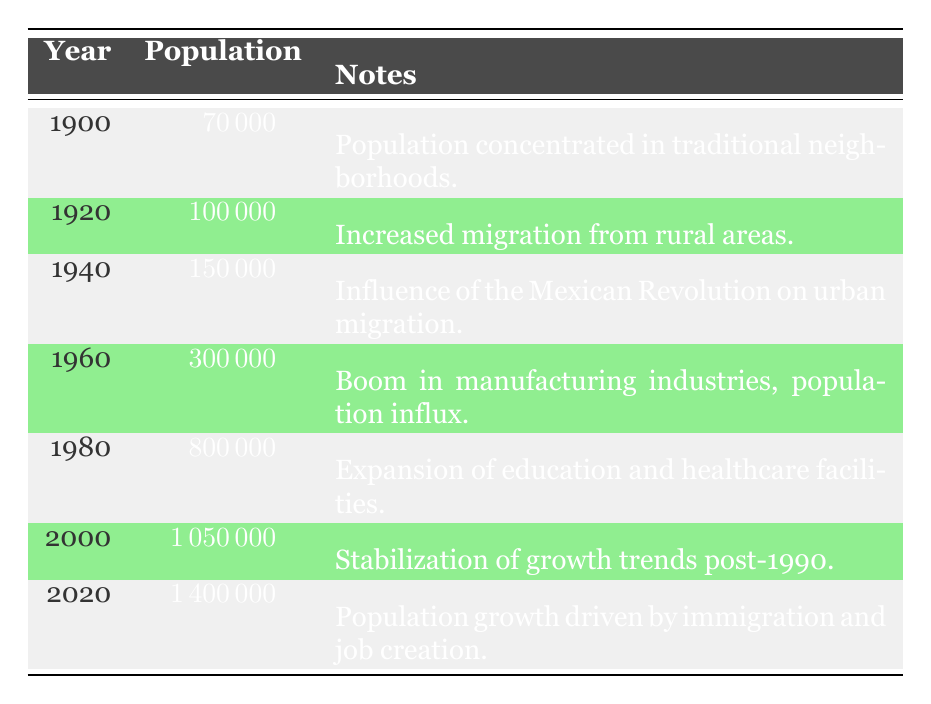What was the population of Monterrey in 1900? The table indicates that the population in 1900 was 70,000.
Answer: 70,000 What year saw a population of 1,000,000? According to the table, the population reached 1,000,000 in 1990.
Answer: 1990 Which year had the highest population growth compared to the previous decade? The decade with the most significant increase occurred from 1970 to 1980, where the population grew from 600,000 to 800,000, an increase of 200,000.
Answer: 1970 to 1980 Was the population of Monterrey less than 1,000,000 in 1990? No, the table shows that the population was indeed 1,000,000 in 1990, meaning it was not less.
Answer: No What was the population difference between 1940 and 1920? The populations were 150,000 in 1940 and 100,000 in 1920, so the difference is 150,000 - 100,000 = 50,000.
Answer: 50,000 In which years did the population double compared to the previous recorded population? The population doubled between 1940 (150,000) and 1950 (200,000), and again between 1960 (300,000) and 1970 (600,000).
Answer: 1940 to 1950 and 1960 to 1970 What was the population of Monterrey in 2020 compared to 1900? The population in 2020 was 1,400,000, which shows a significant increase compared to 70,000 in 1900. Specifically, the difference is 1,400,000 - 70,000 = 1,330,000.
Answer: 1,330,000 What changes occurred in Monterrey's population during the 1950s? The population grew from 200,000 in 1950 to 300,000 in 1960, influenced by post-war economic growth.
Answer: Growth from 200,000 to 300,000 Was there a notable increase in Monterrey's population after the year 2000? Yes, from 2000 (1,050,000) to 2010 (1,300,000), the population increased by 250,000.
Answer: Yes During which decade was the population of Monterrey the highest, and what was that population? The highest population was in 2020 with 1,400,000, so the decade is from 2010 to 2020.
Answer: 2020, 1,400,000 